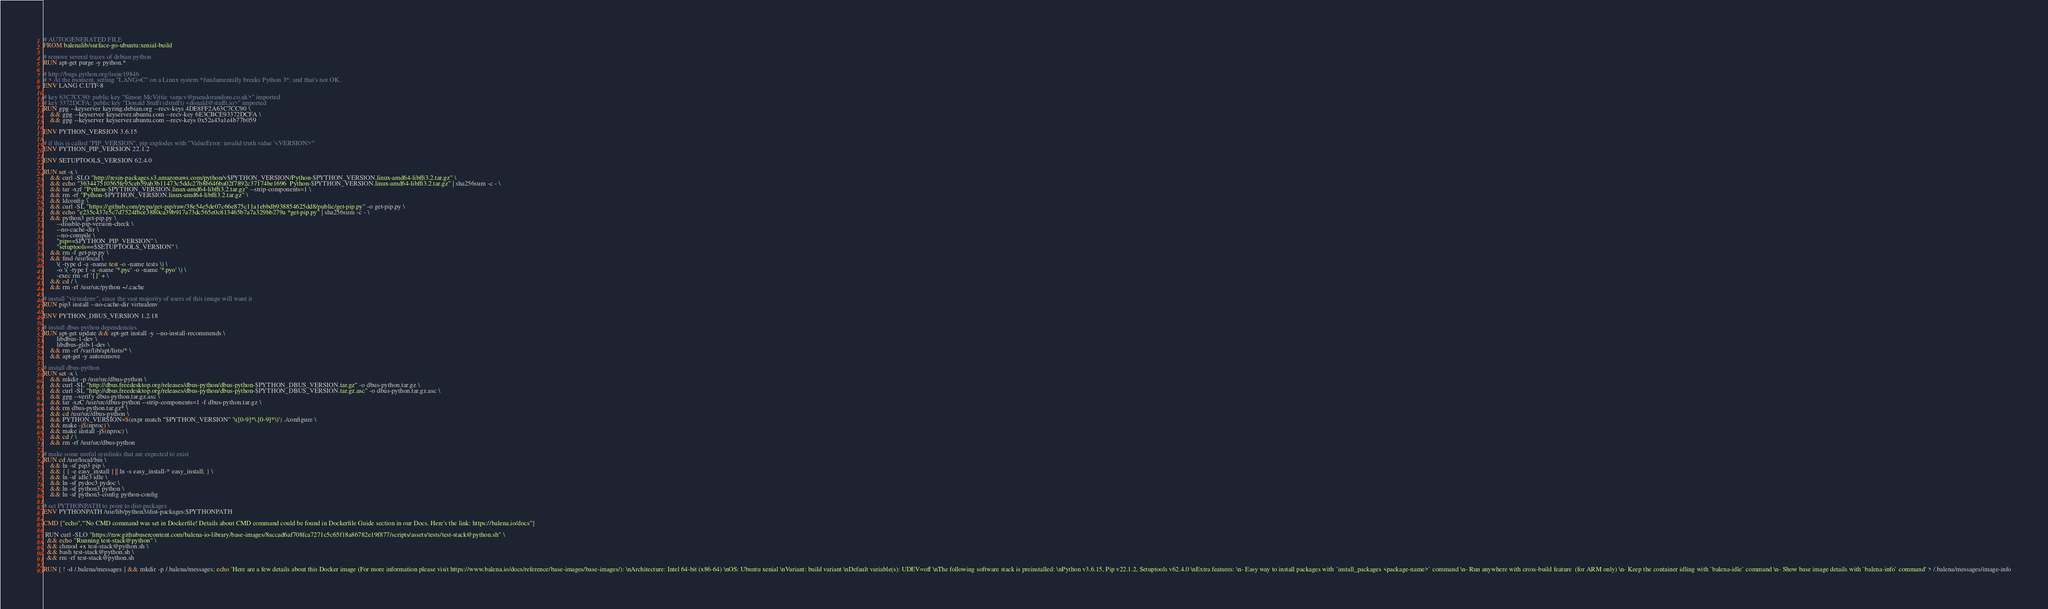Convert code to text. <code><loc_0><loc_0><loc_500><loc_500><_Dockerfile_># AUTOGENERATED FILE
FROM balenalib/surface-go-ubuntu:xenial-build

# remove several traces of debian python
RUN apt-get purge -y python.*

# http://bugs.python.org/issue19846
# > At the moment, setting "LANG=C" on a Linux system *fundamentally breaks Python 3*, and that's not OK.
ENV LANG C.UTF-8

# key 63C7CC90: public key "Simon McVittie <smcv@pseudorandom.co.uk>" imported
# key 3372DCFA: public key "Donald Stufft (dstufft) <donald@stufft.io>" imported
RUN gpg --keyserver keyring.debian.org --recv-keys 4DE8FF2A63C7CC90 \
	&& gpg --keyserver keyserver.ubuntu.com --recv-key 6E3CBCE93372DCFA \
	&& gpg --keyserver keyserver.ubuntu.com --recv-keys 0x52a43a1e4b77b059

ENV PYTHON_VERSION 3.6.15

# if this is called "PIP_VERSION", pip explodes with "ValueError: invalid truth value '<VERSION>'"
ENV PYTHON_PIP_VERSION 22.1.2

ENV SETUPTOOLS_VERSION 62.4.0

RUN set -x \
	&& curl -SLO "http://resin-packages.s3.amazonaws.com/python/v$PYTHON_VERSION/Python-$PYTHON_VERSION.linux-amd64-libffi3.2.tar.gz" \
	&& echo "363447510565fe95ceb59ab3b11473c5ddc27b8b646ba02f7892c37174be1696  Python-$PYTHON_VERSION.linux-amd64-libffi3.2.tar.gz" | sha256sum -c - \
	&& tar -xzf "Python-$PYTHON_VERSION.linux-amd64-libffi3.2.tar.gz" --strip-components=1 \
	&& rm -rf "Python-$PYTHON_VERSION.linux-amd64-libffi3.2.tar.gz" \
	&& ldconfig \
	&& curl -SL "https://github.com/pypa/get-pip/raw/38e54e5de07c66e875c11a1ebbdb938854625dd8/public/get-pip.py" -o get-pip.py \
    && echo "e235c437e5c7d7524fbce3880ca39b917a73dc565e0c813465b7a7a329bb279a *get-pip.py" | sha256sum -c - \
    && python3 get-pip.py \
        --disable-pip-version-check \
        --no-cache-dir \
        --no-compile \
        "pip==$PYTHON_PIP_VERSION" \
        "setuptools==$SETUPTOOLS_VERSION" \
	&& rm -f get-pip.py \
	&& find /usr/local \
		\( -type d -a -name test -o -name tests \) \
		-o \( -type f -a -name '*.pyc' -o -name '*.pyo' \) \
		-exec rm -rf '{}' + \
	&& cd / \
	&& rm -rf /usr/src/python ~/.cache

# install "virtualenv", since the vast majority of users of this image will want it
RUN pip3 install --no-cache-dir virtualenv

ENV PYTHON_DBUS_VERSION 1.2.18

# install dbus-python dependencies 
RUN apt-get update && apt-get install -y --no-install-recommends \
		libdbus-1-dev \
		libdbus-glib-1-dev \
	&& rm -rf /var/lib/apt/lists/* \
	&& apt-get -y autoremove

# install dbus-python
RUN set -x \
	&& mkdir -p /usr/src/dbus-python \
	&& curl -SL "http://dbus.freedesktop.org/releases/dbus-python/dbus-python-$PYTHON_DBUS_VERSION.tar.gz" -o dbus-python.tar.gz \
	&& curl -SL "http://dbus.freedesktop.org/releases/dbus-python/dbus-python-$PYTHON_DBUS_VERSION.tar.gz.asc" -o dbus-python.tar.gz.asc \
	&& gpg --verify dbus-python.tar.gz.asc \
	&& tar -xzC /usr/src/dbus-python --strip-components=1 -f dbus-python.tar.gz \
	&& rm dbus-python.tar.gz* \
	&& cd /usr/src/dbus-python \
	&& PYTHON_VERSION=$(expr match "$PYTHON_VERSION" '\([0-9]*\.[0-9]*\)') ./configure \
	&& make -j$(nproc) \
	&& make install -j$(nproc) \
	&& cd / \
	&& rm -rf /usr/src/dbus-python

# make some useful symlinks that are expected to exist
RUN cd /usr/local/bin \
	&& ln -sf pip3 pip \
	&& { [ -e easy_install ] || ln -s easy_install-* easy_install; } \
	&& ln -sf idle3 idle \
	&& ln -sf pydoc3 pydoc \
	&& ln -sf python3 python \
	&& ln -sf python3-config python-config

# set PYTHONPATH to point to dist-packages
ENV PYTHONPATH /usr/lib/python3/dist-packages:$PYTHONPATH

CMD ["echo","'No CMD command was set in Dockerfile! Details about CMD command could be found in Dockerfile Guide section in our Docs. Here's the link: https://balena.io/docs"]

 RUN curl -SLO "https://raw.githubusercontent.com/balena-io-library/base-images/8accad6af708fca7271c5c65f18a86782e19f877/scripts/assets/tests/test-stack@python.sh" \
  && echo "Running test-stack@python" \
  && chmod +x test-stack@python.sh \
  && bash test-stack@python.sh \
  && rm -rf test-stack@python.sh 

RUN [ ! -d /.balena/messages ] && mkdir -p /.balena/messages; echo 'Here are a few details about this Docker image (For more information please visit https://www.balena.io/docs/reference/base-images/base-images/): \nArchitecture: Intel 64-bit (x86-64) \nOS: Ubuntu xenial \nVariant: build variant \nDefault variable(s): UDEV=off \nThe following software stack is preinstalled: \nPython v3.6.15, Pip v22.1.2, Setuptools v62.4.0 \nExtra features: \n- Easy way to install packages with `install_packages <package-name>` command \n- Run anywhere with cross-build feature  (for ARM only) \n- Keep the container idling with `balena-idle` command \n- Show base image details with `balena-info` command' > /.balena/messages/image-info</code> 